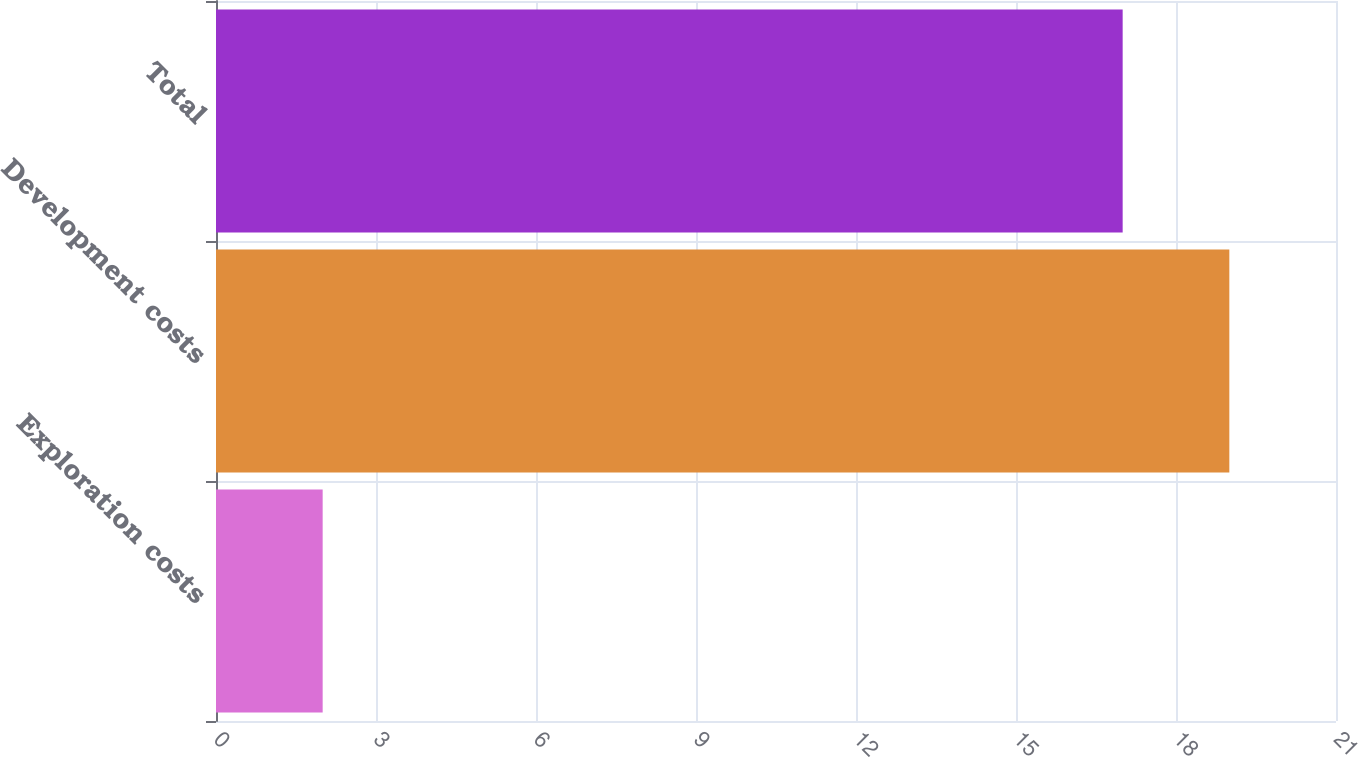Convert chart to OTSL. <chart><loc_0><loc_0><loc_500><loc_500><bar_chart><fcel>Exploration costs<fcel>Development costs<fcel>Total<nl><fcel>2<fcel>19<fcel>17<nl></chart> 